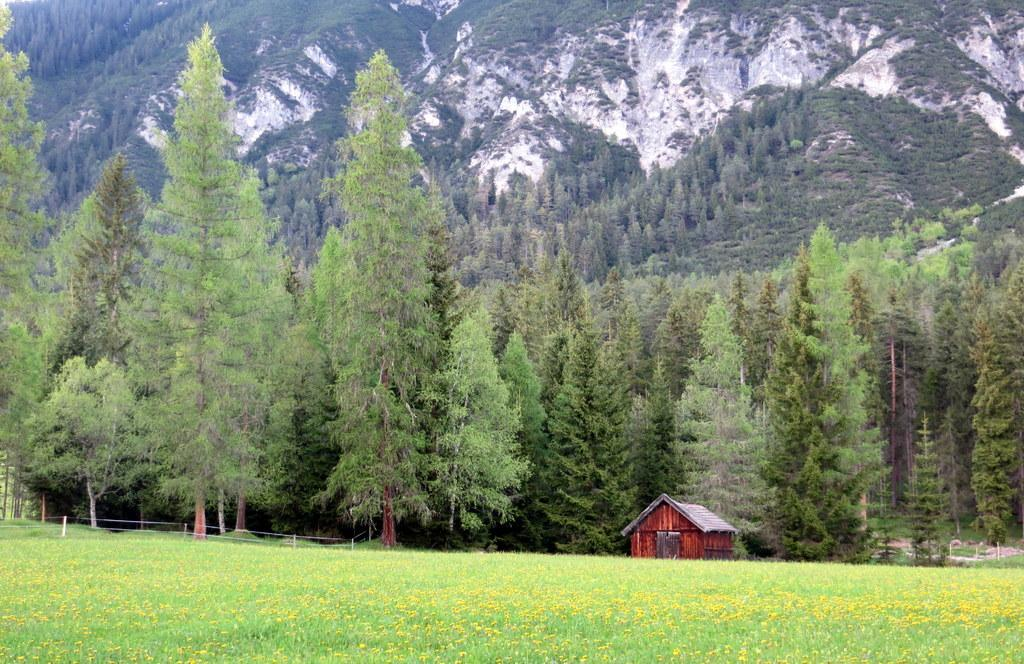What type of scenery is depicted in the image? The image contains a beautiful scenery. What is the dominant vegetation in the image? There is a lot of grass in the image. Are there any trees in the image? Yes, there are trees in the image. What structures can be seen in the image? There is a small hut in front of the trees. What is the background of the image? There is a big mountain behind the trees. What type of nut is being cracked by the insect in the image? There is no nut or insect present in the image. 